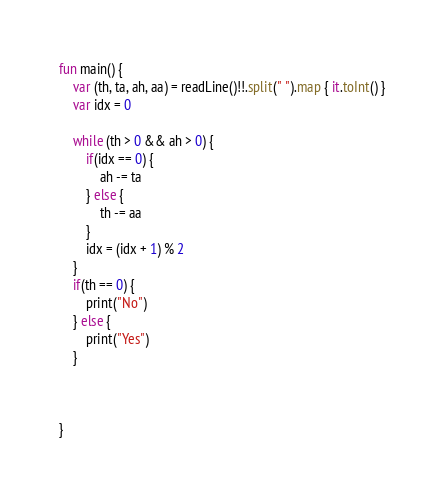<code> <loc_0><loc_0><loc_500><loc_500><_Kotlin_>

fun main() {
    var (th, ta, ah, aa) = readLine()!!.split(" ").map { it.toInt() }
    var idx = 0

    while (th > 0 && ah > 0) {
        if(idx == 0) {
            ah -= ta
        } else {
            th -= aa
        }
        idx = (idx + 1) % 2
    }
    if(th == 0) {
        print("No")
    } else {
        print("Yes")
    }



}</code> 